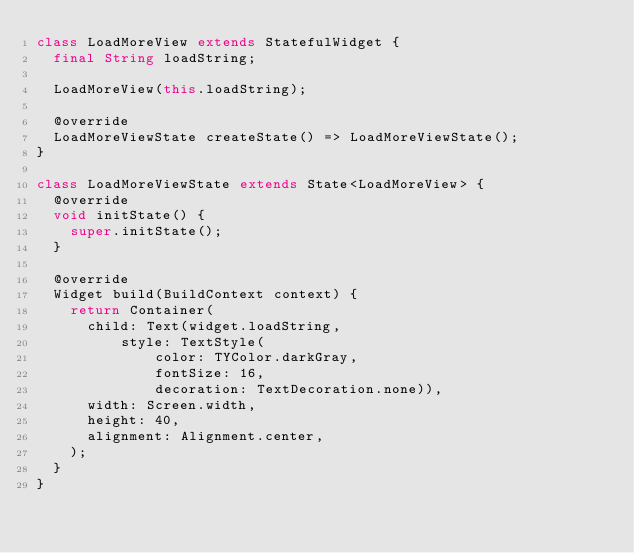Convert code to text. <code><loc_0><loc_0><loc_500><loc_500><_Dart_>class LoadMoreView extends StatefulWidget {
  final String loadString;

  LoadMoreView(this.loadString);

  @override
  LoadMoreViewState createState() => LoadMoreViewState();
}

class LoadMoreViewState extends State<LoadMoreView> {
  @override
  void initState() {
    super.initState();
  }

  @override
  Widget build(BuildContext context) {
    return Container(
      child: Text(widget.loadString,
          style: TextStyle(
              color: TYColor.darkGray,
              fontSize: 16,
              decoration: TextDecoration.none)),
      width: Screen.width,
      height: 40,
      alignment: Alignment.center,
    );
  }
}
</code> 